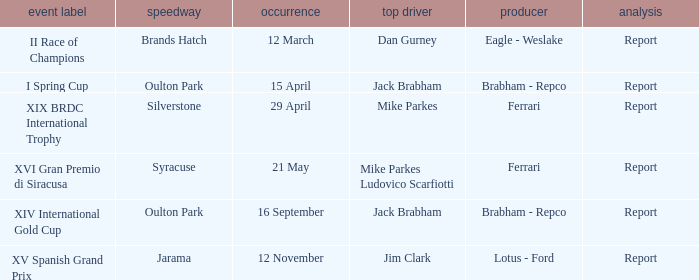What is the name of the race on 16 september? XIV International Gold Cup. 